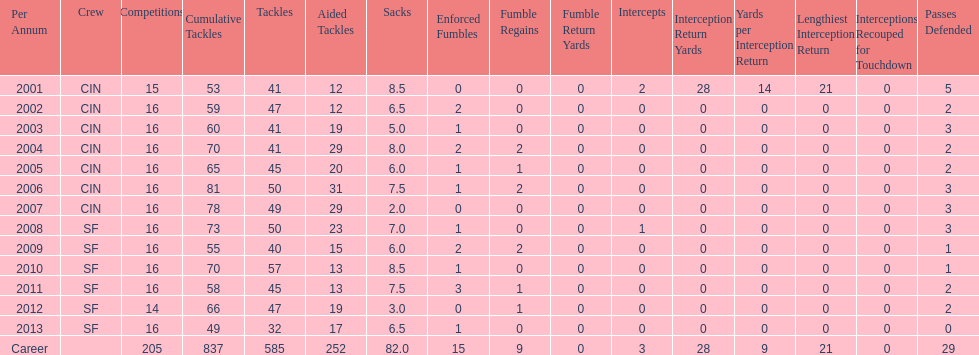How many fumble recoveries did this player have in 2004? 2. 